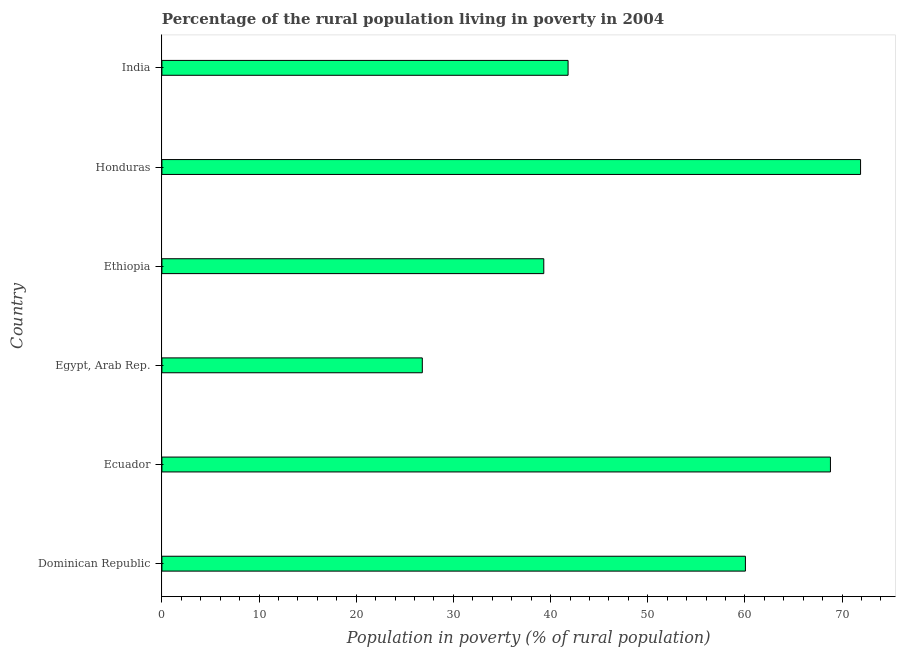What is the title of the graph?
Your answer should be very brief. Percentage of the rural population living in poverty in 2004. What is the label or title of the X-axis?
Your answer should be compact. Population in poverty (% of rural population). What is the label or title of the Y-axis?
Your answer should be very brief. Country. What is the percentage of rural population living below poverty line in India?
Your answer should be compact. 41.8. Across all countries, what is the maximum percentage of rural population living below poverty line?
Your answer should be compact. 71.9. Across all countries, what is the minimum percentage of rural population living below poverty line?
Provide a succinct answer. 26.8. In which country was the percentage of rural population living below poverty line maximum?
Give a very brief answer. Honduras. In which country was the percentage of rural population living below poverty line minimum?
Offer a terse response. Egypt, Arab Rep. What is the sum of the percentage of rural population living below poverty line?
Keep it short and to the point. 308.65. What is the difference between the percentage of rural population living below poverty line in Egypt, Arab Rep. and Honduras?
Give a very brief answer. -45.1. What is the average percentage of rural population living below poverty line per country?
Ensure brevity in your answer.  51.44. What is the median percentage of rural population living below poverty line?
Make the answer very short. 50.92. What is the ratio of the percentage of rural population living below poverty line in Ecuador to that in Honduras?
Provide a short and direct response. 0.96. Is the percentage of rural population living below poverty line in Dominican Republic less than that in Ecuador?
Offer a terse response. Yes. Is the difference between the percentage of rural population living below poverty line in Dominican Republic and Honduras greater than the difference between any two countries?
Provide a short and direct response. No. What is the difference between the highest and the second highest percentage of rural population living below poverty line?
Your answer should be very brief. 3.1. What is the difference between the highest and the lowest percentage of rural population living below poverty line?
Your response must be concise. 45.1. How many bars are there?
Keep it short and to the point. 6. Are all the bars in the graph horizontal?
Your response must be concise. Yes. What is the Population in poverty (% of rural population) in Dominican Republic?
Make the answer very short. 60.05. What is the Population in poverty (% of rural population) of Ecuador?
Ensure brevity in your answer.  68.8. What is the Population in poverty (% of rural population) of Egypt, Arab Rep.?
Make the answer very short. 26.8. What is the Population in poverty (% of rural population) of Ethiopia?
Your answer should be very brief. 39.3. What is the Population in poverty (% of rural population) of Honduras?
Your response must be concise. 71.9. What is the Population in poverty (% of rural population) of India?
Ensure brevity in your answer.  41.8. What is the difference between the Population in poverty (% of rural population) in Dominican Republic and Ecuador?
Keep it short and to the point. -8.75. What is the difference between the Population in poverty (% of rural population) in Dominican Republic and Egypt, Arab Rep.?
Provide a short and direct response. 33.25. What is the difference between the Population in poverty (% of rural population) in Dominican Republic and Ethiopia?
Offer a very short reply. 20.75. What is the difference between the Population in poverty (% of rural population) in Dominican Republic and Honduras?
Ensure brevity in your answer.  -11.85. What is the difference between the Population in poverty (% of rural population) in Dominican Republic and India?
Your answer should be very brief. 18.25. What is the difference between the Population in poverty (% of rural population) in Ecuador and Egypt, Arab Rep.?
Provide a succinct answer. 42. What is the difference between the Population in poverty (% of rural population) in Ecuador and Ethiopia?
Provide a succinct answer. 29.5. What is the difference between the Population in poverty (% of rural population) in Ecuador and Honduras?
Offer a terse response. -3.1. What is the difference between the Population in poverty (% of rural population) in Ecuador and India?
Keep it short and to the point. 27. What is the difference between the Population in poverty (% of rural population) in Egypt, Arab Rep. and Ethiopia?
Ensure brevity in your answer.  -12.5. What is the difference between the Population in poverty (% of rural population) in Egypt, Arab Rep. and Honduras?
Your response must be concise. -45.1. What is the difference between the Population in poverty (% of rural population) in Egypt, Arab Rep. and India?
Your answer should be compact. -15. What is the difference between the Population in poverty (% of rural population) in Ethiopia and Honduras?
Provide a succinct answer. -32.6. What is the difference between the Population in poverty (% of rural population) in Ethiopia and India?
Give a very brief answer. -2.5. What is the difference between the Population in poverty (% of rural population) in Honduras and India?
Your answer should be compact. 30.1. What is the ratio of the Population in poverty (% of rural population) in Dominican Republic to that in Ecuador?
Give a very brief answer. 0.87. What is the ratio of the Population in poverty (% of rural population) in Dominican Republic to that in Egypt, Arab Rep.?
Give a very brief answer. 2.24. What is the ratio of the Population in poverty (% of rural population) in Dominican Republic to that in Ethiopia?
Ensure brevity in your answer.  1.53. What is the ratio of the Population in poverty (% of rural population) in Dominican Republic to that in Honduras?
Keep it short and to the point. 0.83. What is the ratio of the Population in poverty (% of rural population) in Dominican Republic to that in India?
Ensure brevity in your answer.  1.44. What is the ratio of the Population in poverty (% of rural population) in Ecuador to that in Egypt, Arab Rep.?
Give a very brief answer. 2.57. What is the ratio of the Population in poverty (% of rural population) in Ecuador to that in Ethiopia?
Your response must be concise. 1.75. What is the ratio of the Population in poverty (% of rural population) in Ecuador to that in Honduras?
Offer a very short reply. 0.96. What is the ratio of the Population in poverty (% of rural population) in Ecuador to that in India?
Offer a very short reply. 1.65. What is the ratio of the Population in poverty (% of rural population) in Egypt, Arab Rep. to that in Ethiopia?
Your answer should be compact. 0.68. What is the ratio of the Population in poverty (% of rural population) in Egypt, Arab Rep. to that in Honduras?
Keep it short and to the point. 0.37. What is the ratio of the Population in poverty (% of rural population) in Egypt, Arab Rep. to that in India?
Keep it short and to the point. 0.64. What is the ratio of the Population in poverty (% of rural population) in Ethiopia to that in Honduras?
Give a very brief answer. 0.55. What is the ratio of the Population in poverty (% of rural population) in Ethiopia to that in India?
Provide a short and direct response. 0.94. What is the ratio of the Population in poverty (% of rural population) in Honduras to that in India?
Provide a short and direct response. 1.72. 